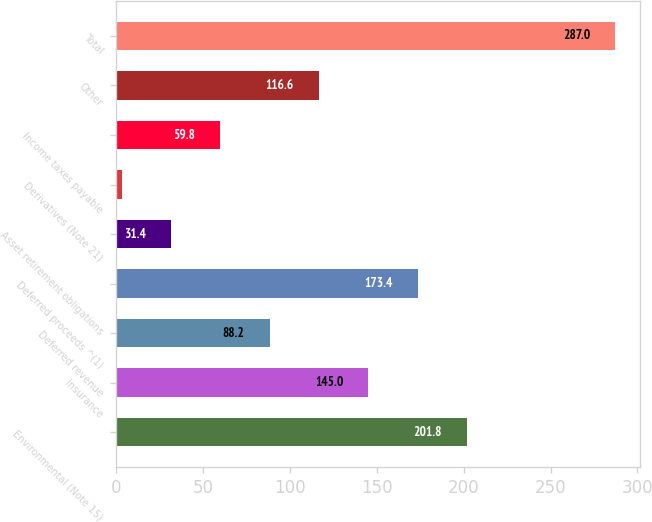Convert chart. <chart><loc_0><loc_0><loc_500><loc_500><bar_chart><fcel>Environmental (Note 15)<fcel>Insurance<fcel>Deferred revenue<fcel>Deferred proceeds ^(1)<fcel>Asset retirement obligations<fcel>Derivatives (Note 21)<fcel>Income taxes payable<fcel>Other<fcel>Total<nl><fcel>201.8<fcel>145<fcel>88.2<fcel>173.4<fcel>31.4<fcel>3<fcel>59.8<fcel>116.6<fcel>287<nl></chart> 